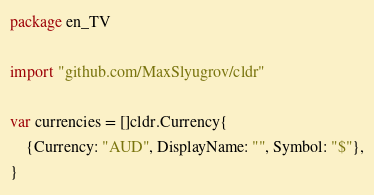<code> <loc_0><loc_0><loc_500><loc_500><_Go_>package en_TV

import "github.com/MaxSlyugrov/cldr"

var currencies = []cldr.Currency{
	{Currency: "AUD", DisplayName: "", Symbol: "$"},
}
</code> 